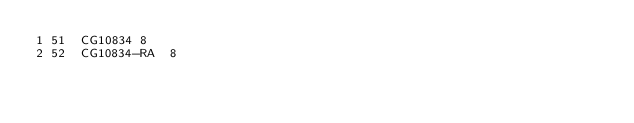<code> <loc_0><loc_0><loc_500><loc_500><_SQL_>1	51	CG10834	8
2	52	CG10834-RA	8
</code> 